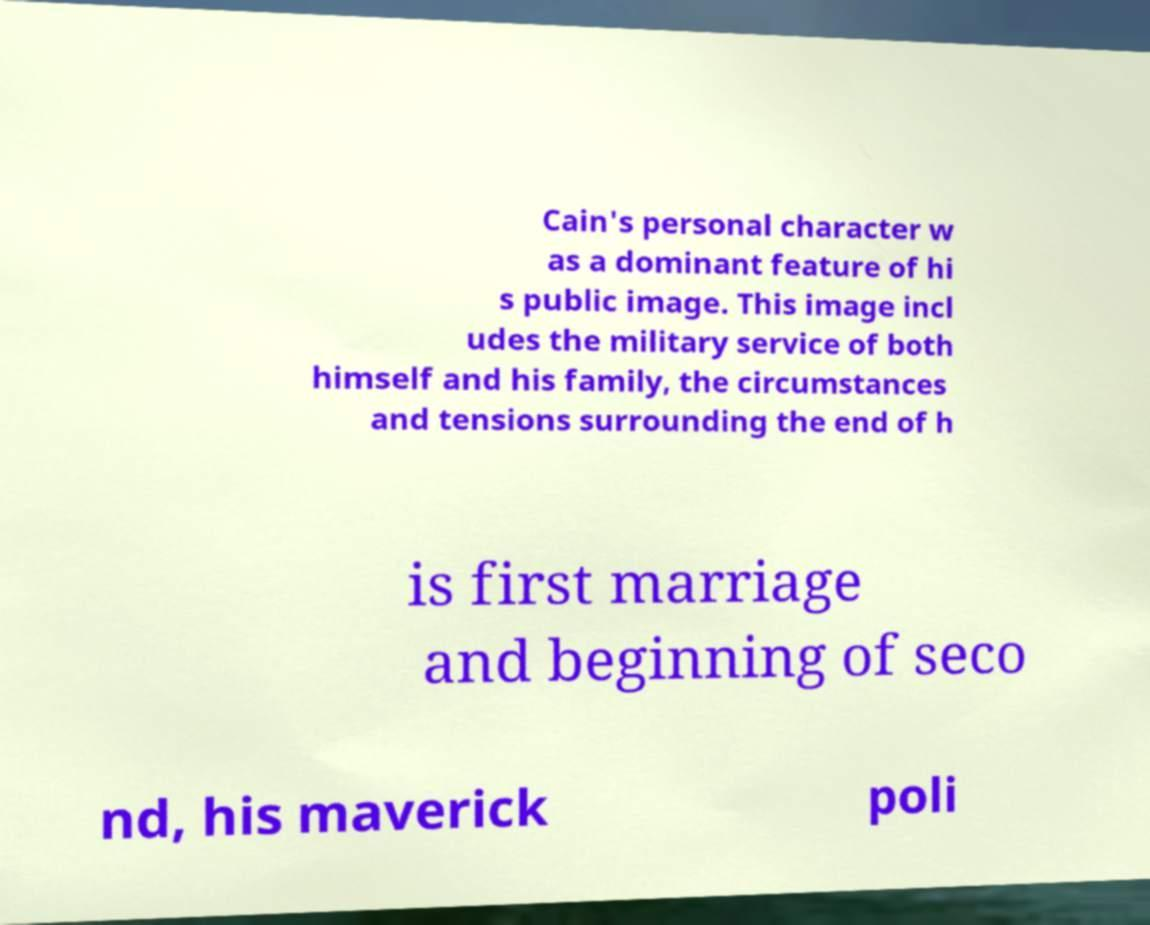Can you read and provide the text displayed in the image?This photo seems to have some interesting text. Can you extract and type it out for me? Cain's personal character w as a dominant feature of hi s public image. This image incl udes the military service of both himself and his family, the circumstances and tensions surrounding the end of h is first marriage and beginning of seco nd, his maverick poli 